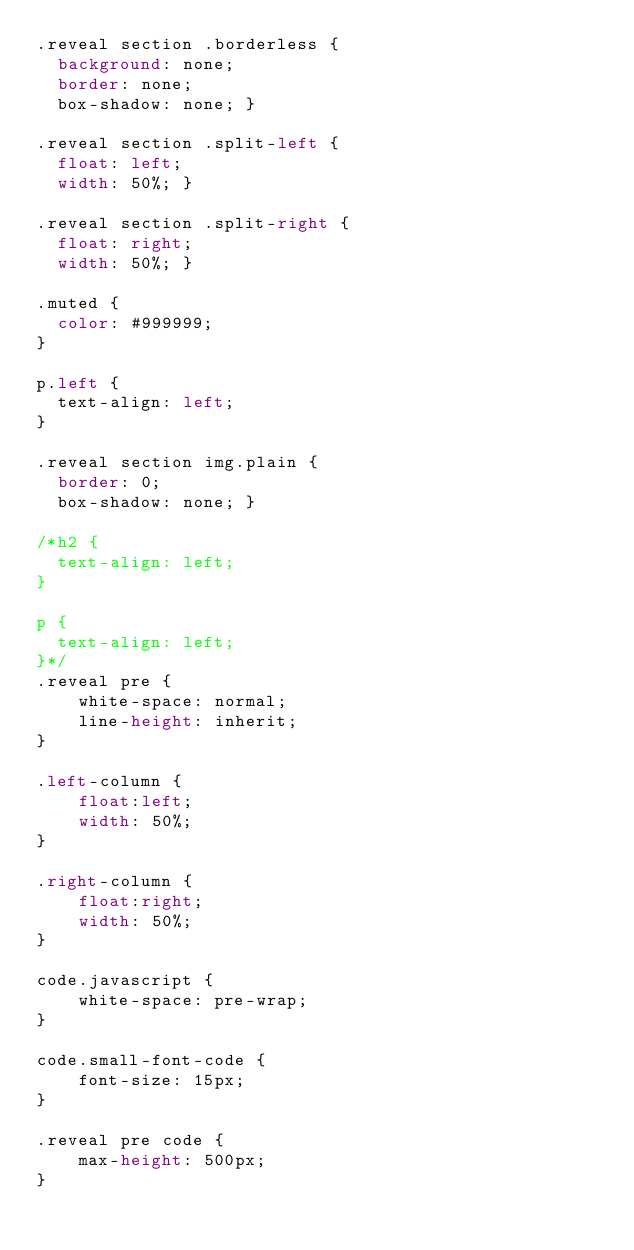Convert code to text. <code><loc_0><loc_0><loc_500><loc_500><_CSS_>.reveal section .borderless {
  background: none;
  border: none;
  box-shadow: none; }

.reveal section .split-left {
  float: left;
  width: 50%; }

.reveal section .split-right {
  float: right;
  width: 50%; }

.muted {
  color: #999999;
}

p.left {
  text-align: left;
}

.reveal section img.plain {
  border: 0;
  box-shadow: none; }

/*h2 {
  text-align: left;
}

p {
  text-align: left;
}*/
.reveal pre {
    white-space: normal;
    line-height: inherit;
}

.left-column {
    float:left;
    width: 50%;
}

.right-column {
    float:right;
    width: 50%;
}

code.javascript {
    white-space: pre-wrap;
}

code.small-font-code {
    font-size: 15px;
}

.reveal pre code {
    max-height: 500px;
}
</code> 